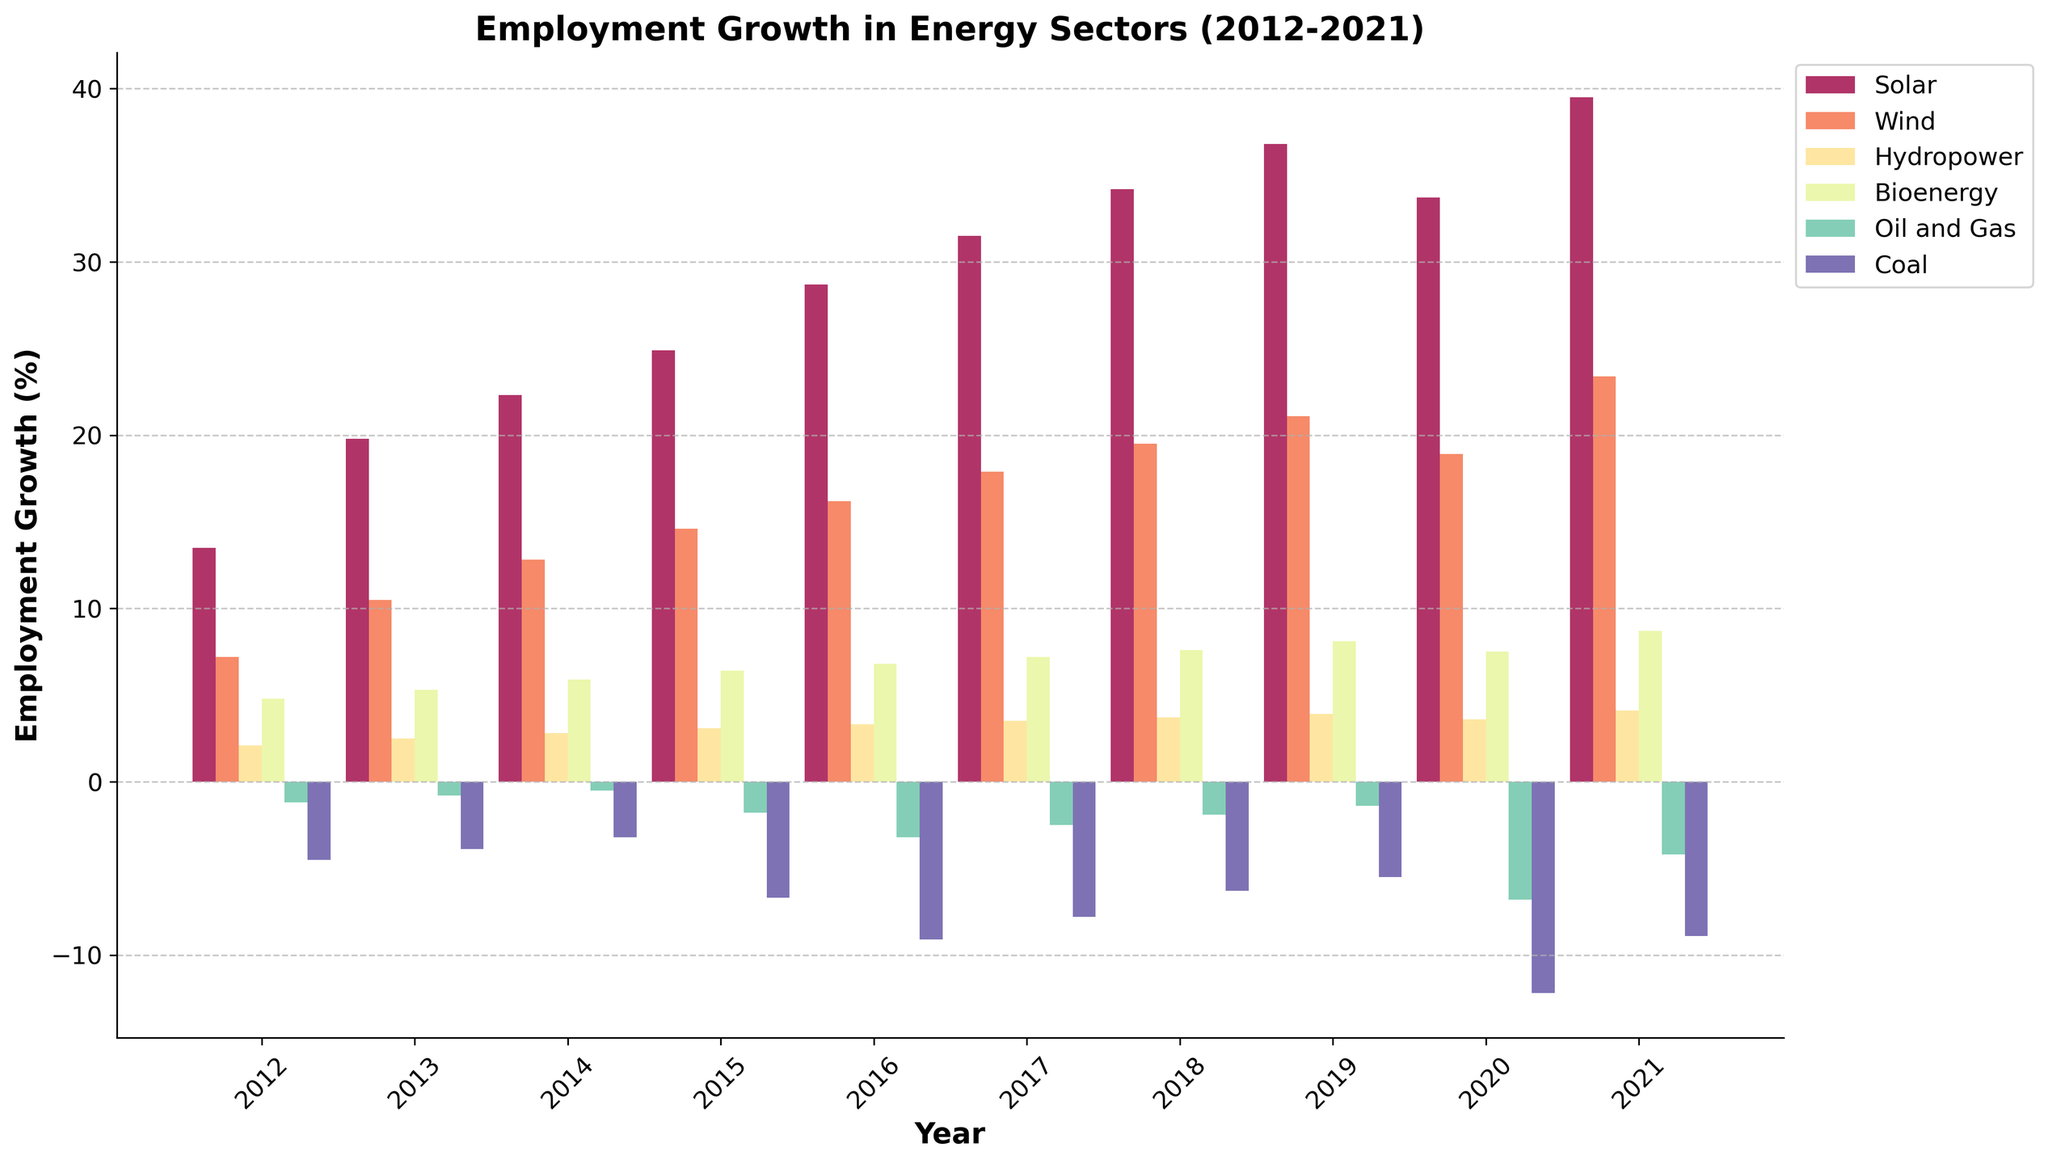What was the trend in employment growth for the Solar sector from 2012 to 2021? To determine the trend in employment growth for the Solar sector from 2012 to 2021, we need to observe the height of the bars corresponding to the Solar sector across these years. The heights consistently increase from 13.5% in 2012 to 39.5% in 2021, except for a slight dip in 2020.
Answer: Increasing with a slight dip in 2020 Compare the employment growth between Wind and Coal sectors in 2021. Observing the bars for Wind and Coal sectors in 2021, Wind shows a much higher employment growth at 23.4%, whereas Coal shows a growth rate of -8.9%.
Answer: Wind is higher Which sector had the highest employment growth in 2018? In 2018, we compare the heights of bars for all sectors. The Solar sector has the highest employment growth at 34.2%.
Answer: Solar What was the percentage difference in employment growth between Bioenergy and Oil and Gas in 2020? The employment growth for Bioenergy in 2020 is 7.5%, and for Oil and Gas, it is -6.8%. The difference is calculated as 7.5 - (-6.8) = 7.5 + 6.8 = 14.3%.
Answer: 14.3% How did the employment growth in the Hydropower sector change from 2015 to 2019? Observing the Hydropower bars for 2015 and 2019, in 2015, the growth was 3.1%, and in 2019, it was 3.9%. The change is calculated by subtracting 3.1 from 3.9, which is an increase of 0.8%.
Answer: Increased by 0.8% Which renewable energy sector showed the most consistent growth over the past decade? By observing all renewable energy sectors, we see that Wind shows a consistent upward trend in its bar heights from 7.2% in 2012 to 23.4% in 2021 without any dips.
Answer: Wind Compare the employment growth in Solar and Oil and Gas sectors in 2016. In 2016, the bar for the Solar sector shows an employment growth of 28.7%, whereas the Oil and Gas sector shows a growth rate of -3.2%.
Answer: Solar is higher Calculate the average employment growth in the Coal sector over the decade. The Coal sector’s employment growth values are -4.5, -3.9, -3.2, -6.7, -9.1, -7.8, -6.3, -5.5, -12.2, and -8.9. Summing these values = -68.1. The average is -68.1/10 = -6.81%.
Answer: -6.81% How much did the employment growth in the Solar sector increase from 2012 to 2021? In 2012, the Solar sector had an employment growth of 13.5%, and in 2021, it was 39.5%. The increase is calculated as 39.5 - 13.5 = 26%.
Answer: 26% Which traditional energy sector experienced the largest decline in employment growth in 2020? Observing the bars for traditional sectors (Oil and Gas, Coal) in 2020, Oil and Gas shows -6.8%, and Coal shows -12.2%. The largest decline is seen in Coal.
Answer: Coal 